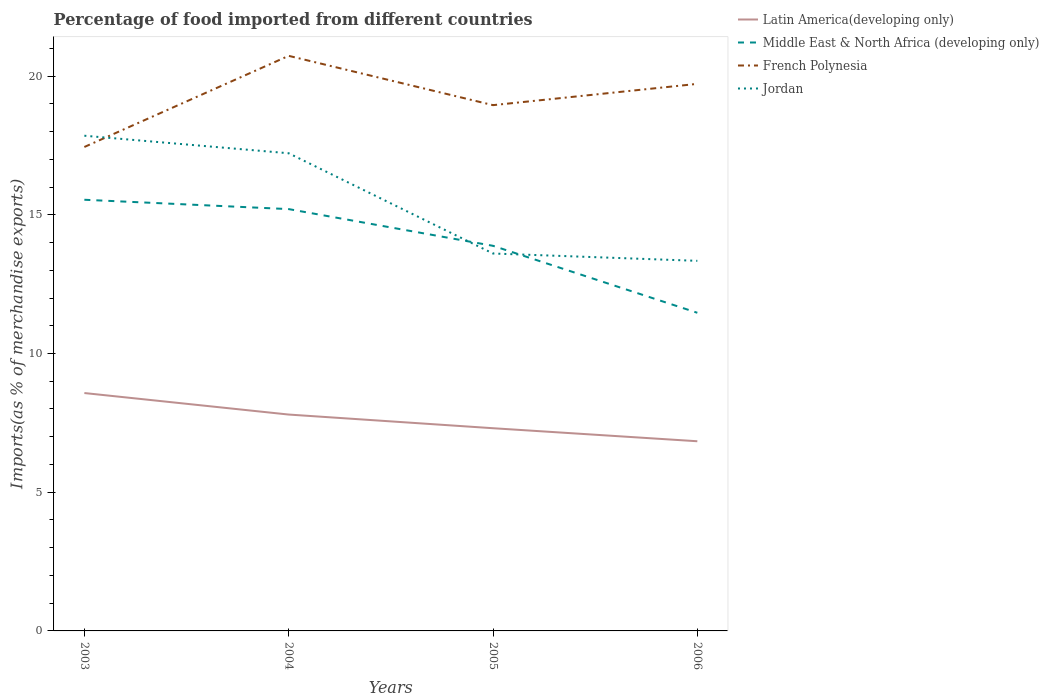How many different coloured lines are there?
Your response must be concise. 4. Across all years, what is the maximum percentage of imports to different countries in Middle East & North Africa (developing only)?
Your answer should be compact. 11.47. What is the total percentage of imports to different countries in Latin America(developing only) in the graph?
Your response must be concise. 0.78. What is the difference between the highest and the second highest percentage of imports to different countries in Jordan?
Provide a succinct answer. 4.51. Are the values on the major ticks of Y-axis written in scientific E-notation?
Provide a short and direct response. No. Does the graph contain grids?
Your answer should be very brief. No. Where does the legend appear in the graph?
Your answer should be very brief. Top right. What is the title of the graph?
Offer a very short reply. Percentage of food imported from different countries. What is the label or title of the X-axis?
Offer a terse response. Years. What is the label or title of the Y-axis?
Offer a very short reply. Imports(as % of merchandise exports). What is the Imports(as % of merchandise exports) in Latin America(developing only) in 2003?
Offer a very short reply. 8.57. What is the Imports(as % of merchandise exports) in Middle East & North Africa (developing only) in 2003?
Give a very brief answer. 15.54. What is the Imports(as % of merchandise exports) of French Polynesia in 2003?
Your answer should be compact. 17.44. What is the Imports(as % of merchandise exports) in Jordan in 2003?
Give a very brief answer. 17.85. What is the Imports(as % of merchandise exports) of Latin America(developing only) in 2004?
Provide a succinct answer. 7.8. What is the Imports(as % of merchandise exports) of Middle East & North Africa (developing only) in 2004?
Make the answer very short. 15.2. What is the Imports(as % of merchandise exports) in French Polynesia in 2004?
Your answer should be very brief. 20.73. What is the Imports(as % of merchandise exports) of Jordan in 2004?
Make the answer very short. 17.22. What is the Imports(as % of merchandise exports) of Latin America(developing only) in 2005?
Give a very brief answer. 7.31. What is the Imports(as % of merchandise exports) of Middle East & North Africa (developing only) in 2005?
Keep it short and to the point. 13.88. What is the Imports(as % of merchandise exports) in French Polynesia in 2005?
Give a very brief answer. 18.95. What is the Imports(as % of merchandise exports) in Jordan in 2005?
Provide a short and direct response. 13.6. What is the Imports(as % of merchandise exports) of Latin America(developing only) in 2006?
Give a very brief answer. 6.84. What is the Imports(as % of merchandise exports) in Middle East & North Africa (developing only) in 2006?
Ensure brevity in your answer.  11.47. What is the Imports(as % of merchandise exports) of French Polynesia in 2006?
Your answer should be very brief. 19.72. What is the Imports(as % of merchandise exports) of Jordan in 2006?
Keep it short and to the point. 13.34. Across all years, what is the maximum Imports(as % of merchandise exports) of Latin America(developing only)?
Ensure brevity in your answer.  8.57. Across all years, what is the maximum Imports(as % of merchandise exports) of Middle East & North Africa (developing only)?
Keep it short and to the point. 15.54. Across all years, what is the maximum Imports(as % of merchandise exports) of French Polynesia?
Keep it short and to the point. 20.73. Across all years, what is the maximum Imports(as % of merchandise exports) of Jordan?
Offer a very short reply. 17.85. Across all years, what is the minimum Imports(as % of merchandise exports) in Latin America(developing only)?
Keep it short and to the point. 6.84. Across all years, what is the minimum Imports(as % of merchandise exports) in Middle East & North Africa (developing only)?
Offer a terse response. 11.47. Across all years, what is the minimum Imports(as % of merchandise exports) of French Polynesia?
Make the answer very short. 17.44. Across all years, what is the minimum Imports(as % of merchandise exports) in Jordan?
Your answer should be compact. 13.34. What is the total Imports(as % of merchandise exports) of Latin America(developing only) in the graph?
Offer a terse response. 30.52. What is the total Imports(as % of merchandise exports) in Middle East & North Africa (developing only) in the graph?
Provide a succinct answer. 56.1. What is the total Imports(as % of merchandise exports) of French Polynesia in the graph?
Your response must be concise. 76.84. What is the total Imports(as % of merchandise exports) in Jordan in the graph?
Provide a short and direct response. 62.01. What is the difference between the Imports(as % of merchandise exports) of Latin America(developing only) in 2003 and that in 2004?
Provide a short and direct response. 0.78. What is the difference between the Imports(as % of merchandise exports) of Middle East & North Africa (developing only) in 2003 and that in 2004?
Provide a short and direct response. 0.34. What is the difference between the Imports(as % of merchandise exports) in French Polynesia in 2003 and that in 2004?
Make the answer very short. -3.29. What is the difference between the Imports(as % of merchandise exports) in Jordan in 2003 and that in 2004?
Provide a succinct answer. 0.63. What is the difference between the Imports(as % of merchandise exports) in Latin America(developing only) in 2003 and that in 2005?
Make the answer very short. 1.27. What is the difference between the Imports(as % of merchandise exports) of Middle East & North Africa (developing only) in 2003 and that in 2005?
Your answer should be compact. 1.66. What is the difference between the Imports(as % of merchandise exports) of French Polynesia in 2003 and that in 2005?
Provide a succinct answer. -1.51. What is the difference between the Imports(as % of merchandise exports) of Jordan in 2003 and that in 2005?
Make the answer very short. 4.25. What is the difference between the Imports(as % of merchandise exports) in Latin America(developing only) in 2003 and that in 2006?
Offer a very short reply. 1.74. What is the difference between the Imports(as % of merchandise exports) of Middle East & North Africa (developing only) in 2003 and that in 2006?
Provide a short and direct response. 4.07. What is the difference between the Imports(as % of merchandise exports) of French Polynesia in 2003 and that in 2006?
Keep it short and to the point. -2.28. What is the difference between the Imports(as % of merchandise exports) of Jordan in 2003 and that in 2006?
Offer a terse response. 4.51. What is the difference between the Imports(as % of merchandise exports) of Latin America(developing only) in 2004 and that in 2005?
Your answer should be very brief. 0.49. What is the difference between the Imports(as % of merchandise exports) in Middle East & North Africa (developing only) in 2004 and that in 2005?
Give a very brief answer. 1.32. What is the difference between the Imports(as % of merchandise exports) in French Polynesia in 2004 and that in 2005?
Make the answer very short. 1.78. What is the difference between the Imports(as % of merchandise exports) of Jordan in 2004 and that in 2005?
Ensure brevity in your answer.  3.61. What is the difference between the Imports(as % of merchandise exports) in Latin America(developing only) in 2004 and that in 2006?
Offer a very short reply. 0.96. What is the difference between the Imports(as % of merchandise exports) of Middle East & North Africa (developing only) in 2004 and that in 2006?
Provide a succinct answer. 3.74. What is the difference between the Imports(as % of merchandise exports) of French Polynesia in 2004 and that in 2006?
Provide a succinct answer. 1.01. What is the difference between the Imports(as % of merchandise exports) of Jordan in 2004 and that in 2006?
Offer a very short reply. 3.88. What is the difference between the Imports(as % of merchandise exports) of Latin America(developing only) in 2005 and that in 2006?
Offer a terse response. 0.47. What is the difference between the Imports(as % of merchandise exports) in Middle East & North Africa (developing only) in 2005 and that in 2006?
Keep it short and to the point. 2.41. What is the difference between the Imports(as % of merchandise exports) of French Polynesia in 2005 and that in 2006?
Offer a terse response. -0.77. What is the difference between the Imports(as % of merchandise exports) of Jordan in 2005 and that in 2006?
Ensure brevity in your answer.  0.26. What is the difference between the Imports(as % of merchandise exports) of Latin America(developing only) in 2003 and the Imports(as % of merchandise exports) of Middle East & North Africa (developing only) in 2004?
Your answer should be compact. -6.63. What is the difference between the Imports(as % of merchandise exports) of Latin America(developing only) in 2003 and the Imports(as % of merchandise exports) of French Polynesia in 2004?
Provide a succinct answer. -12.15. What is the difference between the Imports(as % of merchandise exports) of Latin America(developing only) in 2003 and the Imports(as % of merchandise exports) of Jordan in 2004?
Ensure brevity in your answer.  -8.64. What is the difference between the Imports(as % of merchandise exports) in Middle East & North Africa (developing only) in 2003 and the Imports(as % of merchandise exports) in French Polynesia in 2004?
Give a very brief answer. -5.19. What is the difference between the Imports(as % of merchandise exports) of Middle East & North Africa (developing only) in 2003 and the Imports(as % of merchandise exports) of Jordan in 2004?
Offer a terse response. -1.68. What is the difference between the Imports(as % of merchandise exports) of French Polynesia in 2003 and the Imports(as % of merchandise exports) of Jordan in 2004?
Provide a succinct answer. 0.23. What is the difference between the Imports(as % of merchandise exports) in Latin America(developing only) in 2003 and the Imports(as % of merchandise exports) in Middle East & North Africa (developing only) in 2005?
Provide a succinct answer. -5.31. What is the difference between the Imports(as % of merchandise exports) of Latin America(developing only) in 2003 and the Imports(as % of merchandise exports) of French Polynesia in 2005?
Make the answer very short. -10.38. What is the difference between the Imports(as % of merchandise exports) in Latin America(developing only) in 2003 and the Imports(as % of merchandise exports) in Jordan in 2005?
Keep it short and to the point. -5.03. What is the difference between the Imports(as % of merchandise exports) in Middle East & North Africa (developing only) in 2003 and the Imports(as % of merchandise exports) in French Polynesia in 2005?
Your answer should be very brief. -3.41. What is the difference between the Imports(as % of merchandise exports) of Middle East & North Africa (developing only) in 2003 and the Imports(as % of merchandise exports) of Jordan in 2005?
Offer a terse response. 1.94. What is the difference between the Imports(as % of merchandise exports) in French Polynesia in 2003 and the Imports(as % of merchandise exports) in Jordan in 2005?
Make the answer very short. 3.84. What is the difference between the Imports(as % of merchandise exports) in Latin America(developing only) in 2003 and the Imports(as % of merchandise exports) in Middle East & North Africa (developing only) in 2006?
Provide a short and direct response. -2.89. What is the difference between the Imports(as % of merchandise exports) of Latin America(developing only) in 2003 and the Imports(as % of merchandise exports) of French Polynesia in 2006?
Your answer should be compact. -11.14. What is the difference between the Imports(as % of merchandise exports) in Latin America(developing only) in 2003 and the Imports(as % of merchandise exports) in Jordan in 2006?
Give a very brief answer. -4.77. What is the difference between the Imports(as % of merchandise exports) of Middle East & North Africa (developing only) in 2003 and the Imports(as % of merchandise exports) of French Polynesia in 2006?
Keep it short and to the point. -4.18. What is the difference between the Imports(as % of merchandise exports) in Middle East & North Africa (developing only) in 2003 and the Imports(as % of merchandise exports) in Jordan in 2006?
Your response must be concise. 2.2. What is the difference between the Imports(as % of merchandise exports) in French Polynesia in 2003 and the Imports(as % of merchandise exports) in Jordan in 2006?
Ensure brevity in your answer.  4.1. What is the difference between the Imports(as % of merchandise exports) in Latin America(developing only) in 2004 and the Imports(as % of merchandise exports) in Middle East & North Africa (developing only) in 2005?
Your response must be concise. -6.08. What is the difference between the Imports(as % of merchandise exports) in Latin America(developing only) in 2004 and the Imports(as % of merchandise exports) in French Polynesia in 2005?
Your answer should be compact. -11.15. What is the difference between the Imports(as % of merchandise exports) in Latin America(developing only) in 2004 and the Imports(as % of merchandise exports) in Jordan in 2005?
Provide a short and direct response. -5.81. What is the difference between the Imports(as % of merchandise exports) in Middle East & North Africa (developing only) in 2004 and the Imports(as % of merchandise exports) in French Polynesia in 2005?
Give a very brief answer. -3.75. What is the difference between the Imports(as % of merchandise exports) of Middle East & North Africa (developing only) in 2004 and the Imports(as % of merchandise exports) of Jordan in 2005?
Provide a short and direct response. 1.6. What is the difference between the Imports(as % of merchandise exports) of French Polynesia in 2004 and the Imports(as % of merchandise exports) of Jordan in 2005?
Your answer should be very brief. 7.12. What is the difference between the Imports(as % of merchandise exports) in Latin America(developing only) in 2004 and the Imports(as % of merchandise exports) in Middle East & North Africa (developing only) in 2006?
Offer a very short reply. -3.67. What is the difference between the Imports(as % of merchandise exports) of Latin America(developing only) in 2004 and the Imports(as % of merchandise exports) of French Polynesia in 2006?
Give a very brief answer. -11.92. What is the difference between the Imports(as % of merchandise exports) of Latin America(developing only) in 2004 and the Imports(as % of merchandise exports) of Jordan in 2006?
Your answer should be very brief. -5.54. What is the difference between the Imports(as % of merchandise exports) of Middle East & North Africa (developing only) in 2004 and the Imports(as % of merchandise exports) of French Polynesia in 2006?
Your answer should be very brief. -4.51. What is the difference between the Imports(as % of merchandise exports) in Middle East & North Africa (developing only) in 2004 and the Imports(as % of merchandise exports) in Jordan in 2006?
Your answer should be compact. 1.86. What is the difference between the Imports(as % of merchandise exports) in French Polynesia in 2004 and the Imports(as % of merchandise exports) in Jordan in 2006?
Offer a terse response. 7.39. What is the difference between the Imports(as % of merchandise exports) of Latin America(developing only) in 2005 and the Imports(as % of merchandise exports) of Middle East & North Africa (developing only) in 2006?
Offer a very short reply. -4.16. What is the difference between the Imports(as % of merchandise exports) of Latin America(developing only) in 2005 and the Imports(as % of merchandise exports) of French Polynesia in 2006?
Make the answer very short. -12.41. What is the difference between the Imports(as % of merchandise exports) of Latin America(developing only) in 2005 and the Imports(as % of merchandise exports) of Jordan in 2006?
Provide a short and direct response. -6.03. What is the difference between the Imports(as % of merchandise exports) in Middle East & North Africa (developing only) in 2005 and the Imports(as % of merchandise exports) in French Polynesia in 2006?
Ensure brevity in your answer.  -5.84. What is the difference between the Imports(as % of merchandise exports) of Middle East & North Africa (developing only) in 2005 and the Imports(as % of merchandise exports) of Jordan in 2006?
Ensure brevity in your answer.  0.54. What is the difference between the Imports(as % of merchandise exports) in French Polynesia in 2005 and the Imports(as % of merchandise exports) in Jordan in 2006?
Your response must be concise. 5.61. What is the average Imports(as % of merchandise exports) in Latin America(developing only) per year?
Keep it short and to the point. 7.63. What is the average Imports(as % of merchandise exports) in Middle East & North Africa (developing only) per year?
Provide a succinct answer. 14.02. What is the average Imports(as % of merchandise exports) of French Polynesia per year?
Offer a very short reply. 19.21. What is the average Imports(as % of merchandise exports) in Jordan per year?
Ensure brevity in your answer.  15.5. In the year 2003, what is the difference between the Imports(as % of merchandise exports) of Latin America(developing only) and Imports(as % of merchandise exports) of Middle East & North Africa (developing only)?
Provide a succinct answer. -6.97. In the year 2003, what is the difference between the Imports(as % of merchandise exports) in Latin America(developing only) and Imports(as % of merchandise exports) in French Polynesia?
Your answer should be compact. -8.87. In the year 2003, what is the difference between the Imports(as % of merchandise exports) of Latin America(developing only) and Imports(as % of merchandise exports) of Jordan?
Offer a very short reply. -9.28. In the year 2003, what is the difference between the Imports(as % of merchandise exports) in Middle East & North Africa (developing only) and Imports(as % of merchandise exports) in French Polynesia?
Your response must be concise. -1.9. In the year 2003, what is the difference between the Imports(as % of merchandise exports) in Middle East & North Africa (developing only) and Imports(as % of merchandise exports) in Jordan?
Give a very brief answer. -2.31. In the year 2003, what is the difference between the Imports(as % of merchandise exports) of French Polynesia and Imports(as % of merchandise exports) of Jordan?
Your response must be concise. -0.41. In the year 2004, what is the difference between the Imports(as % of merchandise exports) in Latin America(developing only) and Imports(as % of merchandise exports) in Middle East & North Africa (developing only)?
Your response must be concise. -7.41. In the year 2004, what is the difference between the Imports(as % of merchandise exports) in Latin America(developing only) and Imports(as % of merchandise exports) in French Polynesia?
Make the answer very short. -12.93. In the year 2004, what is the difference between the Imports(as % of merchandise exports) of Latin America(developing only) and Imports(as % of merchandise exports) of Jordan?
Make the answer very short. -9.42. In the year 2004, what is the difference between the Imports(as % of merchandise exports) of Middle East & North Africa (developing only) and Imports(as % of merchandise exports) of French Polynesia?
Ensure brevity in your answer.  -5.52. In the year 2004, what is the difference between the Imports(as % of merchandise exports) of Middle East & North Africa (developing only) and Imports(as % of merchandise exports) of Jordan?
Ensure brevity in your answer.  -2.01. In the year 2004, what is the difference between the Imports(as % of merchandise exports) of French Polynesia and Imports(as % of merchandise exports) of Jordan?
Your answer should be very brief. 3.51. In the year 2005, what is the difference between the Imports(as % of merchandise exports) in Latin America(developing only) and Imports(as % of merchandise exports) in Middle East & North Africa (developing only)?
Your response must be concise. -6.58. In the year 2005, what is the difference between the Imports(as % of merchandise exports) in Latin America(developing only) and Imports(as % of merchandise exports) in French Polynesia?
Your answer should be compact. -11.65. In the year 2005, what is the difference between the Imports(as % of merchandise exports) of Latin America(developing only) and Imports(as % of merchandise exports) of Jordan?
Your answer should be very brief. -6.3. In the year 2005, what is the difference between the Imports(as % of merchandise exports) in Middle East & North Africa (developing only) and Imports(as % of merchandise exports) in French Polynesia?
Your answer should be compact. -5.07. In the year 2005, what is the difference between the Imports(as % of merchandise exports) in Middle East & North Africa (developing only) and Imports(as % of merchandise exports) in Jordan?
Offer a very short reply. 0.28. In the year 2005, what is the difference between the Imports(as % of merchandise exports) in French Polynesia and Imports(as % of merchandise exports) in Jordan?
Offer a terse response. 5.35. In the year 2006, what is the difference between the Imports(as % of merchandise exports) of Latin America(developing only) and Imports(as % of merchandise exports) of Middle East & North Africa (developing only)?
Give a very brief answer. -4.63. In the year 2006, what is the difference between the Imports(as % of merchandise exports) of Latin America(developing only) and Imports(as % of merchandise exports) of French Polynesia?
Make the answer very short. -12.88. In the year 2006, what is the difference between the Imports(as % of merchandise exports) of Latin America(developing only) and Imports(as % of merchandise exports) of Jordan?
Your response must be concise. -6.5. In the year 2006, what is the difference between the Imports(as % of merchandise exports) of Middle East & North Africa (developing only) and Imports(as % of merchandise exports) of French Polynesia?
Offer a terse response. -8.25. In the year 2006, what is the difference between the Imports(as % of merchandise exports) in Middle East & North Africa (developing only) and Imports(as % of merchandise exports) in Jordan?
Make the answer very short. -1.87. In the year 2006, what is the difference between the Imports(as % of merchandise exports) in French Polynesia and Imports(as % of merchandise exports) in Jordan?
Your answer should be very brief. 6.38. What is the ratio of the Imports(as % of merchandise exports) of Latin America(developing only) in 2003 to that in 2004?
Provide a short and direct response. 1.1. What is the ratio of the Imports(as % of merchandise exports) in Middle East & North Africa (developing only) in 2003 to that in 2004?
Offer a very short reply. 1.02. What is the ratio of the Imports(as % of merchandise exports) of French Polynesia in 2003 to that in 2004?
Ensure brevity in your answer.  0.84. What is the ratio of the Imports(as % of merchandise exports) in Jordan in 2003 to that in 2004?
Provide a succinct answer. 1.04. What is the ratio of the Imports(as % of merchandise exports) in Latin America(developing only) in 2003 to that in 2005?
Offer a terse response. 1.17. What is the ratio of the Imports(as % of merchandise exports) of Middle East & North Africa (developing only) in 2003 to that in 2005?
Provide a short and direct response. 1.12. What is the ratio of the Imports(as % of merchandise exports) in French Polynesia in 2003 to that in 2005?
Make the answer very short. 0.92. What is the ratio of the Imports(as % of merchandise exports) of Jordan in 2003 to that in 2005?
Provide a short and direct response. 1.31. What is the ratio of the Imports(as % of merchandise exports) of Latin America(developing only) in 2003 to that in 2006?
Offer a terse response. 1.25. What is the ratio of the Imports(as % of merchandise exports) of Middle East & North Africa (developing only) in 2003 to that in 2006?
Keep it short and to the point. 1.36. What is the ratio of the Imports(as % of merchandise exports) in French Polynesia in 2003 to that in 2006?
Your response must be concise. 0.88. What is the ratio of the Imports(as % of merchandise exports) of Jordan in 2003 to that in 2006?
Make the answer very short. 1.34. What is the ratio of the Imports(as % of merchandise exports) in Latin America(developing only) in 2004 to that in 2005?
Provide a succinct answer. 1.07. What is the ratio of the Imports(as % of merchandise exports) in Middle East & North Africa (developing only) in 2004 to that in 2005?
Make the answer very short. 1.1. What is the ratio of the Imports(as % of merchandise exports) in French Polynesia in 2004 to that in 2005?
Your answer should be very brief. 1.09. What is the ratio of the Imports(as % of merchandise exports) in Jordan in 2004 to that in 2005?
Make the answer very short. 1.27. What is the ratio of the Imports(as % of merchandise exports) of Latin America(developing only) in 2004 to that in 2006?
Your answer should be compact. 1.14. What is the ratio of the Imports(as % of merchandise exports) in Middle East & North Africa (developing only) in 2004 to that in 2006?
Provide a short and direct response. 1.33. What is the ratio of the Imports(as % of merchandise exports) of French Polynesia in 2004 to that in 2006?
Ensure brevity in your answer.  1.05. What is the ratio of the Imports(as % of merchandise exports) of Jordan in 2004 to that in 2006?
Your answer should be compact. 1.29. What is the ratio of the Imports(as % of merchandise exports) in Latin America(developing only) in 2005 to that in 2006?
Ensure brevity in your answer.  1.07. What is the ratio of the Imports(as % of merchandise exports) of Middle East & North Africa (developing only) in 2005 to that in 2006?
Offer a very short reply. 1.21. What is the ratio of the Imports(as % of merchandise exports) in French Polynesia in 2005 to that in 2006?
Give a very brief answer. 0.96. What is the ratio of the Imports(as % of merchandise exports) of Jordan in 2005 to that in 2006?
Your answer should be compact. 1.02. What is the difference between the highest and the second highest Imports(as % of merchandise exports) of Latin America(developing only)?
Offer a very short reply. 0.78. What is the difference between the highest and the second highest Imports(as % of merchandise exports) of Middle East & North Africa (developing only)?
Offer a very short reply. 0.34. What is the difference between the highest and the second highest Imports(as % of merchandise exports) of French Polynesia?
Provide a short and direct response. 1.01. What is the difference between the highest and the second highest Imports(as % of merchandise exports) in Jordan?
Offer a terse response. 0.63. What is the difference between the highest and the lowest Imports(as % of merchandise exports) of Latin America(developing only)?
Offer a terse response. 1.74. What is the difference between the highest and the lowest Imports(as % of merchandise exports) in Middle East & North Africa (developing only)?
Your answer should be compact. 4.07. What is the difference between the highest and the lowest Imports(as % of merchandise exports) of French Polynesia?
Provide a short and direct response. 3.29. What is the difference between the highest and the lowest Imports(as % of merchandise exports) in Jordan?
Your response must be concise. 4.51. 